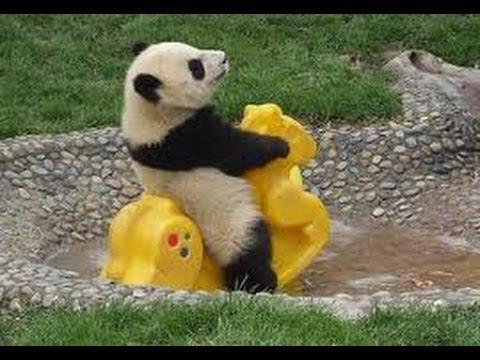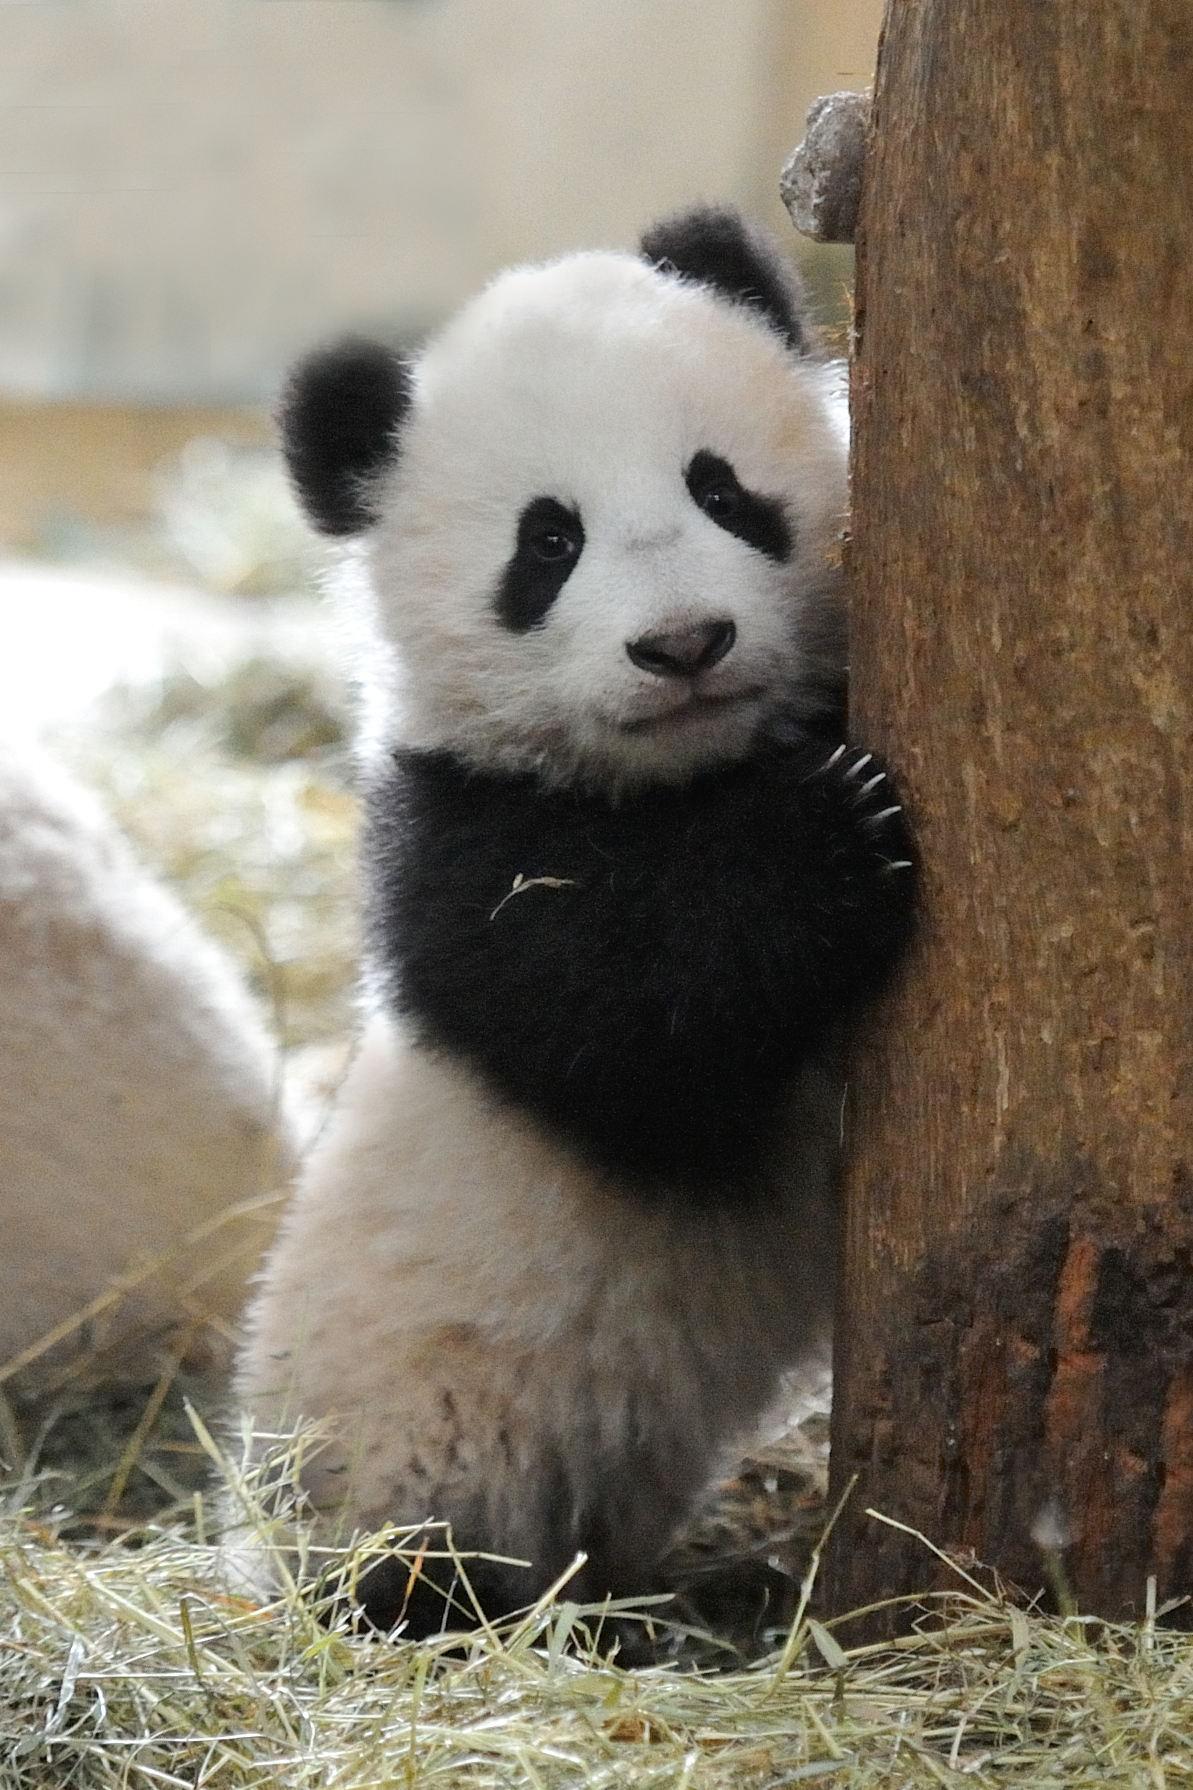The first image is the image on the left, the second image is the image on the right. Evaluate the accuracy of this statement regarding the images: "An image shows one panda playing with a toy, with its front paws grasping the object.". Is it true? Answer yes or no. Yes. 